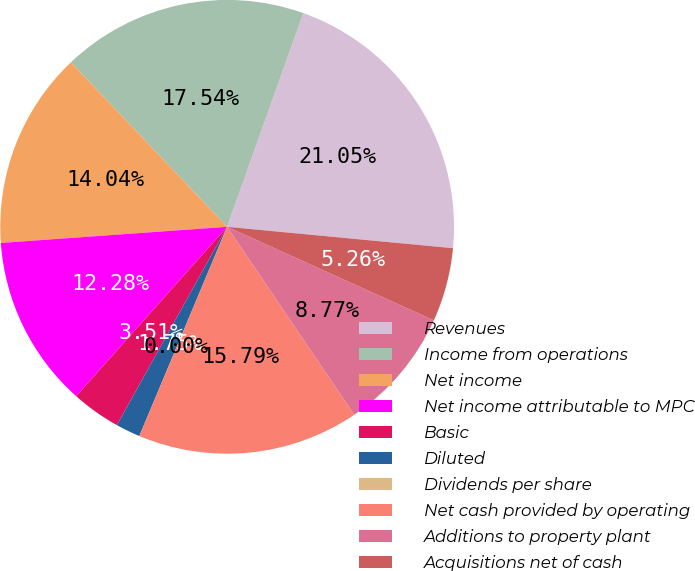<chart> <loc_0><loc_0><loc_500><loc_500><pie_chart><fcel>Revenues<fcel>Income from operations<fcel>Net income<fcel>Net income attributable to MPC<fcel>Basic<fcel>Diluted<fcel>Dividends per share<fcel>Net cash provided by operating<fcel>Additions to property plant<fcel>Acquisitions net of cash<nl><fcel>21.05%<fcel>17.54%<fcel>14.04%<fcel>12.28%<fcel>3.51%<fcel>1.75%<fcel>0.0%<fcel>15.79%<fcel>8.77%<fcel>5.26%<nl></chart> 